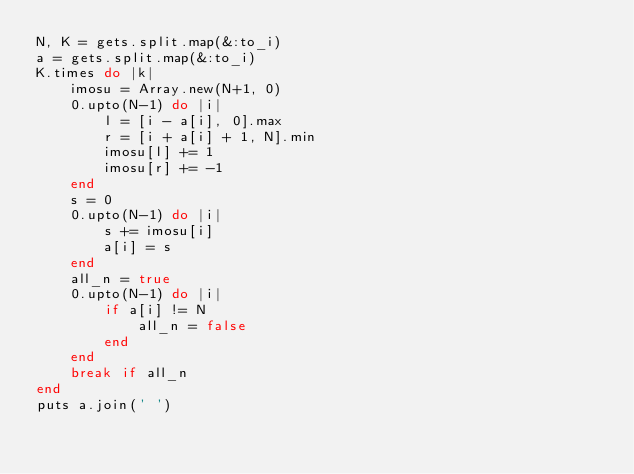<code> <loc_0><loc_0><loc_500><loc_500><_Ruby_>N, K = gets.split.map(&:to_i)
a = gets.split.map(&:to_i)
K.times do |k|
    imosu = Array.new(N+1, 0)
    0.upto(N-1) do |i|
        l = [i - a[i], 0].max
        r = [i + a[i] + 1, N].min
        imosu[l] += 1
        imosu[r] += -1
    end
    s = 0
    0.upto(N-1) do |i|
        s += imosu[i]
        a[i] = s
    end
    all_n = true
    0.upto(N-1) do |i|
        if a[i] != N
            all_n = false
        end
    end
    break if all_n
end
puts a.join(' ')</code> 